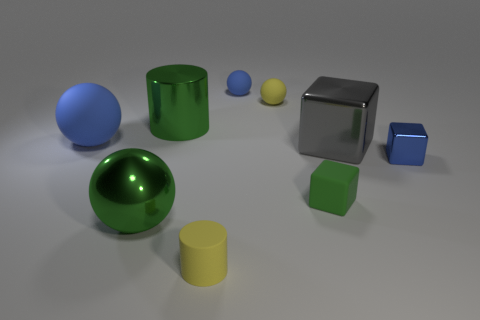Imagine this is a still from a children's educational program. What might the narrator say about shapes and colors? Welcome, young explorers, to a world full of shapes and colors! Today we see round spheres, one as blue as the sky and another as yellow as the sun. There’s also a shining cube, a reminder of ice cubes and sugar cubes, and cylinders like the columns that hold up grand buildings. Each object, with its unique form and color, helps us learn the differences and similarities in the things around us. And what lesson about light and texture might the narrator include? Observe the way light dances on different surfaces, dear friends! Some objects are glossy and reflect light like a calm lake reflects trees, while others are matte and absorb light like a cozy cotton blanket. By noticing these details, we understand that the world is not just shaped by forms, but also by the materials that make it up and the light that reveals it to us. 